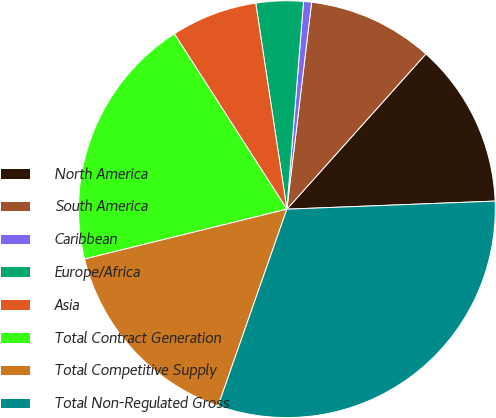Convert chart to OTSL. <chart><loc_0><loc_0><loc_500><loc_500><pie_chart><fcel>North America<fcel>South America<fcel>Caribbean<fcel>Europe/Africa<fcel>Asia<fcel>Total Contract Generation<fcel>Total Competitive Supply<fcel>Total Non-Regulated Gross<nl><fcel>12.76%<fcel>9.73%<fcel>0.62%<fcel>3.66%<fcel>6.69%<fcel>19.77%<fcel>15.8%<fcel>30.97%<nl></chart> 